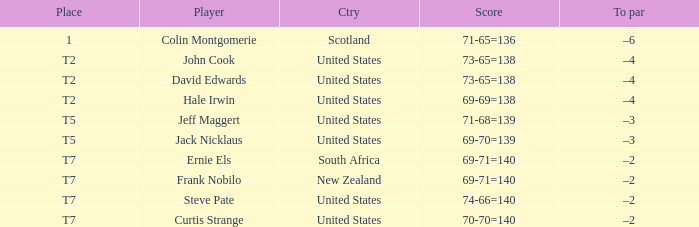Frank Nobilo plays for what country? New Zealand. 